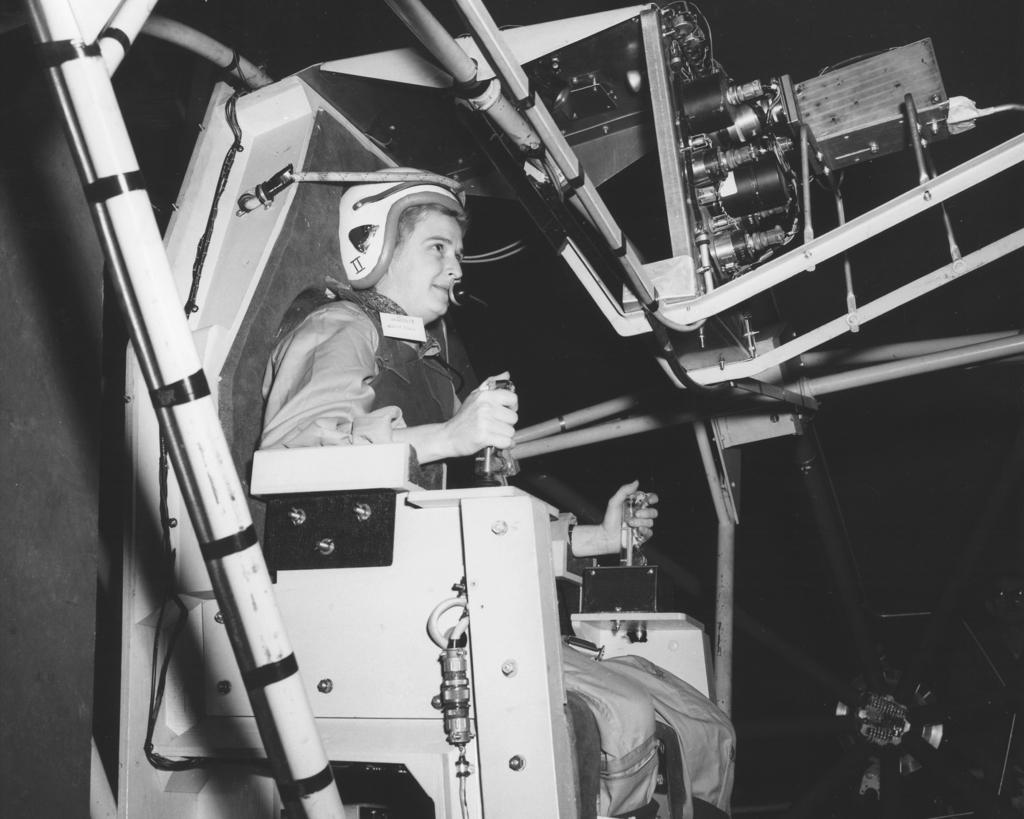Who is present in the image? There is a person in the image. What is the person doing in the image? The person is sitting on a space shuttle seat and operating the space shuttle. What type of kite is the person flying in the image? There is no kite present in the image; the person is operating a space shuttle. How does the person interact with their self in the image? The person is not interacting with their self in the image; they are operating the space shuttle. 